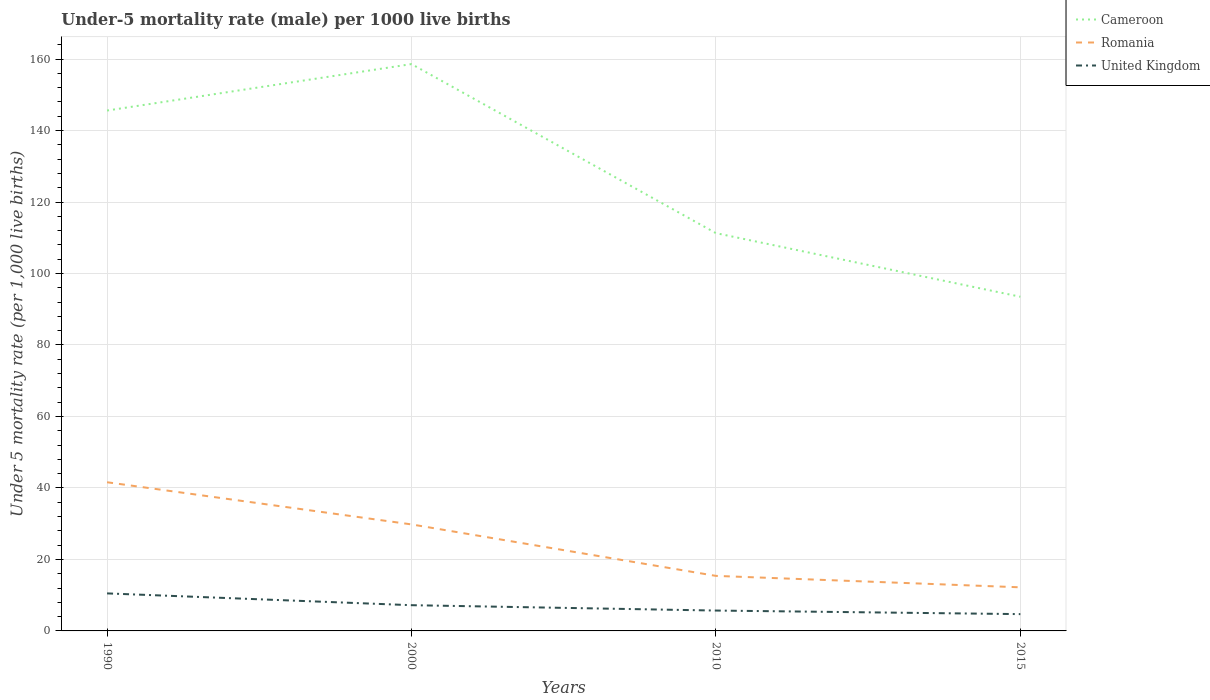How many different coloured lines are there?
Offer a very short reply. 3. Across all years, what is the maximum under-five mortality rate in United Kingdom?
Give a very brief answer. 4.7. In which year was the under-five mortality rate in Romania maximum?
Your answer should be very brief. 2015. What is the total under-five mortality rate in Romania in the graph?
Provide a short and direct response. 11.8. What is the difference between the highest and the second highest under-five mortality rate in Romania?
Provide a short and direct response. 29.4. What is the difference between the highest and the lowest under-five mortality rate in Cameroon?
Make the answer very short. 2. How many lines are there?
Give a very brief answer. 3. What is the difference between two consecutive major ticks on the Y-axis?
Ensure brevity in your answer.  20. Does the graph contain any zero values?
Your answer should be very brief. No. Does the graph contain grids?
Ensure brevity in your answer.  Yes. How many legend labels are there?
Offer a terse response. 3. What is the title of the graph?
Your answer should be very brief. Under-5 mortality rate (male) per 1000 live births. What is the label or title of the X-axis?
Your response must be concise. Years. What is the label or title of the Y-axis?
Provide a succinct answer. Under 5 mortality rate (per 1,0 live births). What is the Under 5 mortality rate (per 1,000 live births) in Cameroon in 1990?
Provide a succinct answer. 145.6. What is the Under 5 mortality rate (per 1,000 live births) of Romania in 1990?
Provide a succinct answer. 41.6. What is the Under 5 mortality rate (per 1,000 live births) in Cameroon in 2000?
Give a very brief answer. 158.6. What is the Under 5 mortality rate (per 1,000 live births) of Romania in 2000?
Your response must be concise. 29.8. What is the Under 5 mortality rate (per 1,000 live births) of United Kingdom in 2000?
Offer a very short reply. 7.2. What is the Under 5 mortality rate (per 1,000 live births) of Cameroon in 2010?
Your response must be concise. 111.3. What is the Under 5 mortality rate (per 1,000 live births) of Cameroon in 2015?
Offer a terse response. 93.5. What is the Under 5 mortality rate (per 1,000 live births) in Romania in 2015?
Ensure brevity in your answer.  12.2. Across all years, what is the maximum Under 5 mortality rate (per 1,000 live births) of Cameroon?
Provide a succinct answer. 158.6. Across all years, what is the maximum Under 5 mortality rate (per 1,000 live births) in Romania?
Offer a very short reply. 41.6. Across all years, what is the maximum Under 5 mortality rate (per 1,000 live births) of United Kingdom?
Your answer should be compact. 10.5. Across all years, what is the minimum Under 5 mortality rate (per 1,000 live births) in Cameroon?
Offer a very short reply. 93.5. Across all years, what is the minimum Under 5 mortality rate (per 1,000 live births) of Romania?
Your response must be concise. 12.2. What is the total Under 5 mortality rate (per 1,000 live births) in Cameroon in the graph?
Make the answer very short. 509. What is the total Under 5 mortality rate (per 1,000 live births) of United Kingdom in the graph?
Make the answer very short. 28.1. What is the difference between the Under 5 mortality rate (per 1,000 live births) in Cameroon in 1990 and that in 2000?
Provide a short and direct response. -13. What is the difference between the Under 5 mortality rate (per 1,000 live births) of United Kingdom in 1990 and that in 2000?
Keep it short and to the point. 3.3. What is the difference between the Under 5 mortality rate (per 1,000 live births) of Cameroon in 1990 and that in 2010?
Make the answer very short. 34.3. What is the difference between the Under 5 mortality rate (per 1,000 live births) of Romania in 1990 and that in 2010?
Give a very brief answer. 26.2. What is the difference between the Under 5 mortality rate (per 1,000 live births) of United Kingdom in 1990 and that in 2010?
Your response must be concise. 4.8. What is the difference between the Under 5 mortality rate (per 1,000 live births) in Cameroon in 1990 and that in 2015?
Provide a short and direct response. 52.1. What is the difference between the Under 5 mortality rate (per 1,000 live births) of Romania in 1990 and that in 2015?
Keep it short and to the point. 29.4. What is the difference between the Under 5 mortality rate (per 1,000 live births) in Cameroon in 2000 and that in 2010?
Offer a terse response. 47.3. What is the difference between the Under 5 mortality rate (per 1,000 live births) of Romania in 2000 and that in 2010?
Ensure brevity in your answer.  14.4. What is the difference between the Under 5 mortality rate (per 1,000 live births) of United Kingdom in 2000 and that in 2010?
Give a very brief answer. 1.5. What is the difference between the Under 5 mortality rate (per 1,000 live births) of Cameroon in 2000 and that in 2015?
Offer a very short reply. 65.1. What is the difference between the Under 5 mortality rate (per 1,000 live births) of United Kingdom in 2000 and that in 2015?
Your answer should be compact. 2.5. What is the difference between the Under 5 mortality rate (per 1,000 live births) in Romania in 2010 and that in 2015?
Offer a very short reply. 3.2. What is the difference between the Under 5 mortality rate (per 1,000 live births) in Cameroon in 1990 and the Under 5 mortality rate (per 1,000 live births) in Romania in 2000?
Offer a very short reply. 115.8. What is the difference between the Under 5 mortality rate (per 1,000 live births) of Cameroon in 1990 and the Under 5 mortality rate (per 1,000 live births) of United Kingdom in 2000?
Give a very brief answer. 138.4. What is the difference between the Under 5 mortality rate (per 1,000 live births) of Romania in 1990 and the Under 5 mortality rate (per 1,000 live births) of United Kingdom in 2000?
Provide a succinct answer. 34.4. What is the difference between the Under 5 mortality rate (per 1,000 live births) of Cameroon in 1990 and the Under 5 mortality rate (per 1,000 live births) of Romania in 2010?
Provide a short and direct response. 130.2. What is the difference between the Under 5 mortality rate (per 1,000 live births) of Cameroon in 1990 and the Under 5 mortality rate (per 1,000 live births) of United Kingdom in 2010?
Your answer should be compact. 139.9. What is the difference between the Under 5 mortality rate (per 1,000 live births) in Romania in 1990 and the Under 5 mortality rate (per 1,000 live births) in United Kingdom in 2010?
Offer a terse response. 35.9. What is the difference between the Under 5 mortality rate (per 1,000 live births) in Cameroon in 1990 and the Under 5 mortality rate (per 1,000 live births) in Romania in 2015?
Provide a short and direct response. 133.4. What is the difference between the Under 5 mortality rate (per 1,000 live births) of Cameroon in 1990 and the Under 5 mortality rate (per 1,000 live births) of United Kingdom in 2015?
Provide a succinct answer. 140.9. What is the difference between the Under 5 mortality rate (per 1,000 live births) in Romania in 1990 and the Under 5 mortality rate (per 1,000 live births) in United Kingdom in 2015?
Ensure brevity in your answer.  36.9. What is the difference between the Under 5 mortality rate (per 1,000 live births) in Cameroon in 2000 and the Under 5 mortality rate (per 1,000 live births) in Romania in 2010?
Offer a terse response. 143.2. What is the difference between the Under 5 mortality rate (per 1,000 live births) of Cameroon in 2000 and the Under 5 mortality rate (per 1,000 live births) of United Kingdom in 2010?
Your response must be concise. 152.9. What is the difference between the Under 5 mortality rate (per 1,000 live births) in Romania in 2000 and the Under 5 mortality rate (per 1,000 live births) in United Kingdom in 2010?
Offer a very short reply. 24.1. What is the difference between the Under 5 mortality rate (per 1,000 live births) in Cameroon in 2000 and the Under 5 mortality rate (per 1,000 live births) in Romania in 2015?
Keep it short and to the point. 146.4. What is the difference between the Under 5 mortality rate (per 1,000 live births) in Cameroon in 2000 and the Under 5 mortality rate (per 1,000 live births) in United Kingdom in 2015?
Ensure brevity in your answer.  153.9. What is the difference between the Under 5 mortality rate (per 1,000 live births) in Romania in 2000 and the Under 5 mortality rate (per 1,000 live births) in United Kingdom in 2015?
Give a very brief answer. 25.1. What is the difference between the Under 5 mortality rate (per 1,000 live births) of Cameroon in 2010 and the Under 5 mortality rate (per 1,000 live births) of Romania in 2015?
Give a very brief answer. 99.1. What is the difference between the Under 5 mortality rate (per 1,000 live births) of Cameroon in 2010 and the Under 5 mortality rate (per 1,000 live births) of United Kingdom in 2015?
Provide a succinct answer. 106.6. What is the difference between the Under 5 mortality rate (per 1,000 live births) of Romania in 2010 and the Under 5 mortality rate (per 1,000 live births) of United Kingdom in 2015?
Provide a short and direct response. 10.7. What is the average Under 5 mortality rate (per 1,000 live births) in Cameroon per year?
Offer a very short reply. 127.25. What is the average Under 5 mortality rate (per 1,000 live births) of Romania per year?
Provide a short and direct response. 24.75. What is the average Under 5 mortality rate (per 1,000 live births) in United Kingdom per year?
Your answer should be very brief. 7.03. In the year 1990, what is the difference between the Under 5 mortality rate (per 1,000 live births) of Cameroon and Under 5 mortality rate (per 1,000 live births) of Romania?
Offer a very short reply. 104. In the year 1990, what is the difference between the Under 5 mortality rate (per 1,000 live births) of Cameroon and Under 5 mortality rate (per 1,000 live births) of United Kingdom?
Offer a terse response. 135.1. In the year 1990, what is the difference between the Under 5 mortality rate (per 1,000 live births) in Romania and Under 5 mortality rate (per 1,000 live births) in United Kingdom?
Offer a terse response. 31.1. In the year 2000, what is the difference between the Under 5 mortality rate (per 1,000 live births) of Cameroon and Under 5 mortality rate (per 1,000 live births) of Romania?
Make the answer very short. 128.8. In the year 2000, what is the difference between the Under 5 mortality rate (per 1,000 live births) of Cameroon and Under 5 mortality rate (per 1,000 live births) of United Kingdom?
Provide a succinct answer. 151.4. In the year 2000, what is the difference between the Under 5 mortality rate (per 1,000 live births) of Romania and Under 5 mortality rate (per 1,000 live births) of United Kingdom?
Offer a very short reply. 22.6. In the year 2010, what is the difference between the Under 5 mortality rate (per 1,000 live births) of Cameroon and Under 5 mortality rate (per 1,000 live births) of Romania?
Make the answer very short. 95.9. In the year 2010, what is the difference between the Under 5 mortality rate (per 1,000 live births) in Cameroon and Under 5 mortality rate (per 1,000 live births) in United Kingdom?
Your answer should be very brief. 105.6. In the year 2015, what is the difference between the Under 5 mortality rate (per 1,000 live births) of Cameroon and Under 5 mortality rate (per 1,000 live births) of Romania?
Provide a short and direct response. 81.3. In the year 2015, what is the difference between the Under 5 mortality rate (per 1,000 live births) of Cameroon and Under 5 mortality rate (per 1,000 live births) of United Kingdom?
Make the answer very short. 88.8. In the year 2015, what is the difference between the Under 5 mortality rate (per 1,000 live births) in Romania and Under 5 mortality rate (per 1,000 live births) in United Kingdom?
Keep it short and to the point. 7.5. What is the ratio of the Under 5 mortality rate (per 1,000 live births) of Cameroon in 1990 to that in 2000?
Your response must be concise. 0.92. What is the ratio of the Under 5 mortality rate (per 1,000 live births) in Romania in 1990 to that in 2000?
Keep it short and to the point. 1.4. What is the ratio of the Under 5 mortality rate (per 1,000 live births) in United Kingdom in 1990 to that in 2000?
Your answer should be very brief. 1.46. What is the ratio of the Under 5 mortality rate (per 1,000 live births) of Cameroon in 1990 to that in 2010?
Offer a very short reply. 1.31. What is the ratio of the Under 5 mortality rate (per 1,000 live births) of Romania in 1990 to that in 2010?
Offer a very short reply. 2.7. What is the ratio of the Under 5 mortality rate (per 1,000 live births) of United Kingdom in 1990 to that in 2010?
Ensure brevity in your answer.  1.84. What is the ratio of the Under 5 mortality rate (per 1,000 live births) in Cameroon in 1990 to that in 2015?
Offer a terse response. 1.56. What is the ratio of the Under 5 mortality rate (per 1,000 live births) of Romania in 1990 to that in 2015?
Ensure brevity in your answer.  3.41. What is the ratio of the Under 5 mortality rate (per 1,000 live births) in United Kingdom in 1990 to that in 2015?
Ensure brevity in your answer.  2.23. What is the ratio of the Under 5 mortality rate (per 1,000 live births) in Cameroon in 2000 to that in 2010?
Your answer should be very brief. 1.43. What is the ratio of the Under 5 mortality rate (per 1,000 live births) in Romania in 2000 to that in 2010?
Give a very brief answer. 1.94. What is the ratio of the Under 5 mortality rate (per 1,000 live births) in United Kingdom in 2000 to that in 2010?
Provide a succinct answer. 1.26. What is the ratio of the Under 5 mortality rate (per 1,000 live births) of Cameroon in 2000 to that in 2015?
Give a very brief answer. 1.7. What is the ratio of the Under 5 mortality rate (per 1,000 live births) in Romania in 2000 to that in 2015?
Ensure brevity in your answer.  2.44. What is the ratio of the Under 5 mortality rate (per 1,000 live births) in United Kingdom in 2000 to that in 2015?
Make the answer very short. 1.53. What is the ratio of the Under 5 mortality rate (per 1,000 live births) in Cameroon in 2010 to that in 2015?
Ensure brevity in your answer.  1.19. What is the ratio of the Under 5 mortality rate (per 1,000 live births) in Romania in 2010 to that in 2015?
Provide a succinct answer. 1.26. What is the ratio of the Under 5 mortality rate (per 1,000 live births) of United Kingdom in 2010 to that in 2015?
Provide a succinct answer. 1.21. What is the difference between the highest and the second highest Under 5 mortality rate (per 1,000 live births) of Cameroon?
Give a very brief answer. 13. What is the difference between the highest and the lowest Under 5 mortality rate (per 1,000 live births) in Cameroon?
Make the answer very short. 65.1. What is the difference between the highest and the lowest Under 5 mortality rate (per 1,000 live births) of Romania?
Keep it short and to the point. 29.4. What is the difference between the highest and the lowest Under 5 mortality rate (per 1,000 live births) of United Kingdom?
Keep it short and to the point. 5.8. 